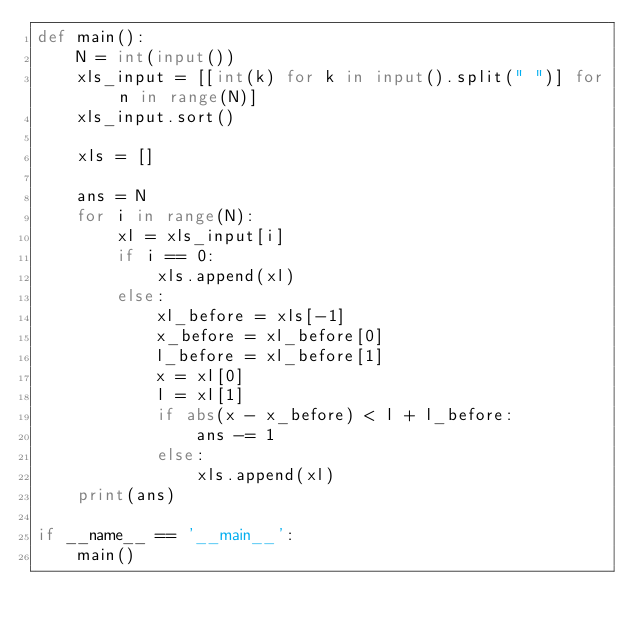<code> <loc_0><loc_0><loc_500><loc_500><_Python_>def main():
    N = int(input())
    xls_input = [[int(k) for k in input().split(" ")] for n in range(N)]
    xls_input.sort()

    xls = []

    ans = N
    for i in range(N):
        xl = xls_input[i]
        if i == 0:
            xls.append(xl)
        else:
            xl_before = xls[-1]
            x_before = xl_before[0]
            l_before = xl_before[1]
            x = xl[0]
            l = xl[1]
            if abs(x - x_before) < l + l_before:
                ans -= 1
            else:
                xls.append(xl)
    print(ans)

if __name__ == '__main__':
    main()</code> 